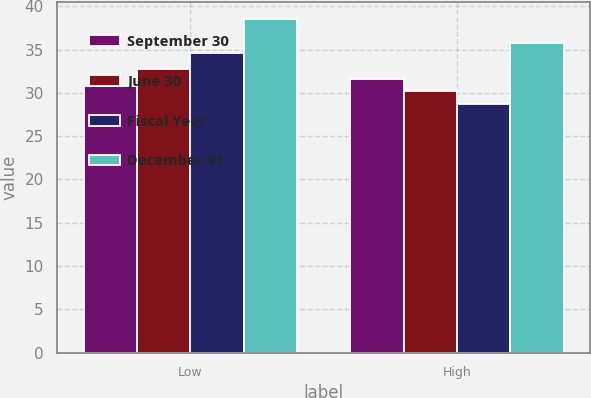Convert chart. <chart><loc_0><loc_0><loc_500><loc_500><stacked_bar_chart><ecel><fcel>Low<fcel>High<nl><fcel>September 30<fcel>30.84<fcel>31.61<nl><fcel>June 30<fcel>32.8<fcel>30.25<nl><fcel>Fiscal Year<fcel>34.63<fcel>28.66<nl><fcel>December 31<fcel>38.51<fcel>35.78<nl></chart> 